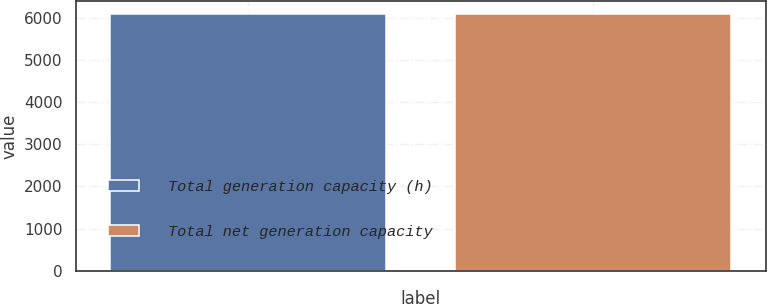<chart> <loc_0><loc_0><loc_500><loc_500><bar_chart><fcel>Total generation capacity (h)<fcel>Total net generation capacity<nl><fcel>6085<fcel>6085.1<nl></chart> 